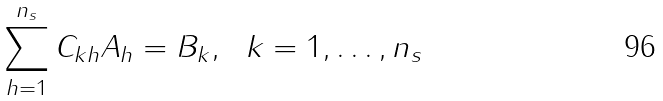<formula> <loc_0><loc_0><loc_500><loc_500>\sum _ { h = 1 } ^ { n _ { s } } C _ { k h } A _ { h } = B _ { k } , \ \ k = 1 , \dots , n _ { s }</formula> 